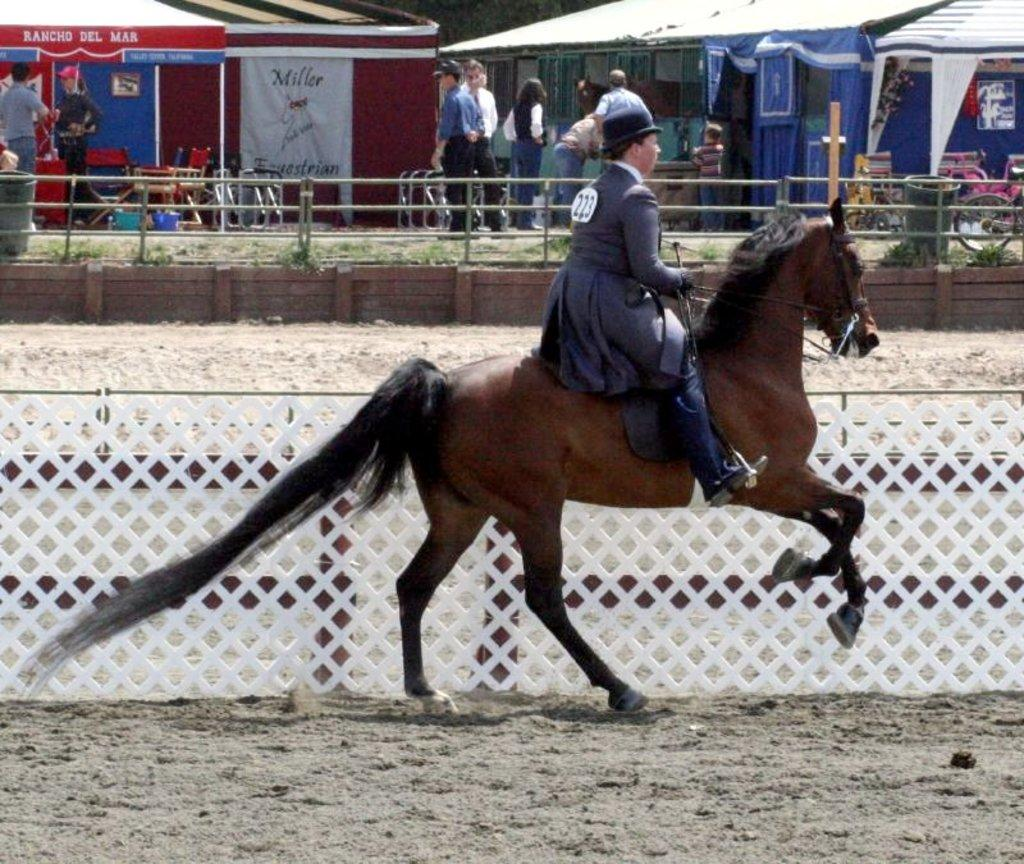What is the man in the image doing? The man is riding a horse in the image. What can be seen in the background of the image? There is a fence and people standing in the background of the image. What type of structures are visible in the background? There are tents in the background of the image. What type of cork can be seen in the man's hand while riding the horse? There is no cork present in the image; the man is riding a horse and there is no indication of him holding a cork. 